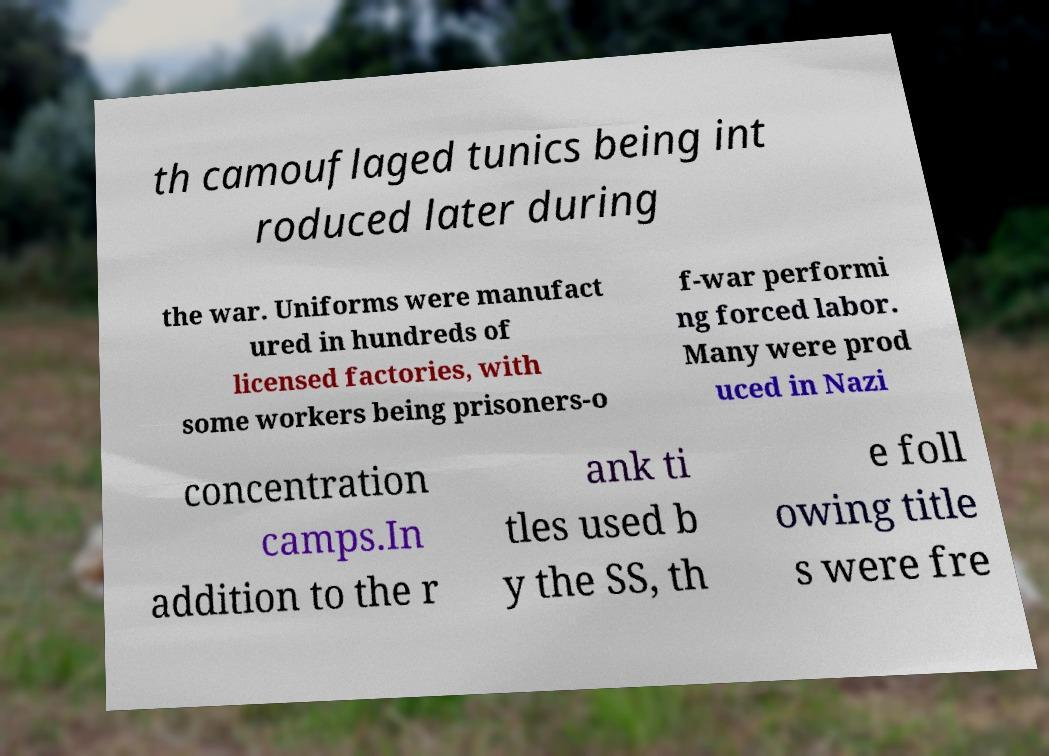Could you assist in decoding the text presented in this image and type it out clearly? th camouflaged tunics being int roduced later during the war. Uniforms were manufact ured in hundreds of licensed factories, with some workers being prisoners-o f-war performi ng forced labor. Many were prod uced in Nazi concentration camps.In addition to the r ank ti tles used b y the SS, th e foll owing title s were fre 